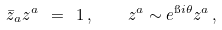<formula> <loc_0><loc_0><loc_500><loc_500>\bar { z } _ { a } z ^ { a } \ = \ 1 \, , \quad z ^ { a } \sim e ^ { \i i \theta } z ^ { a } \, ,</formula> 